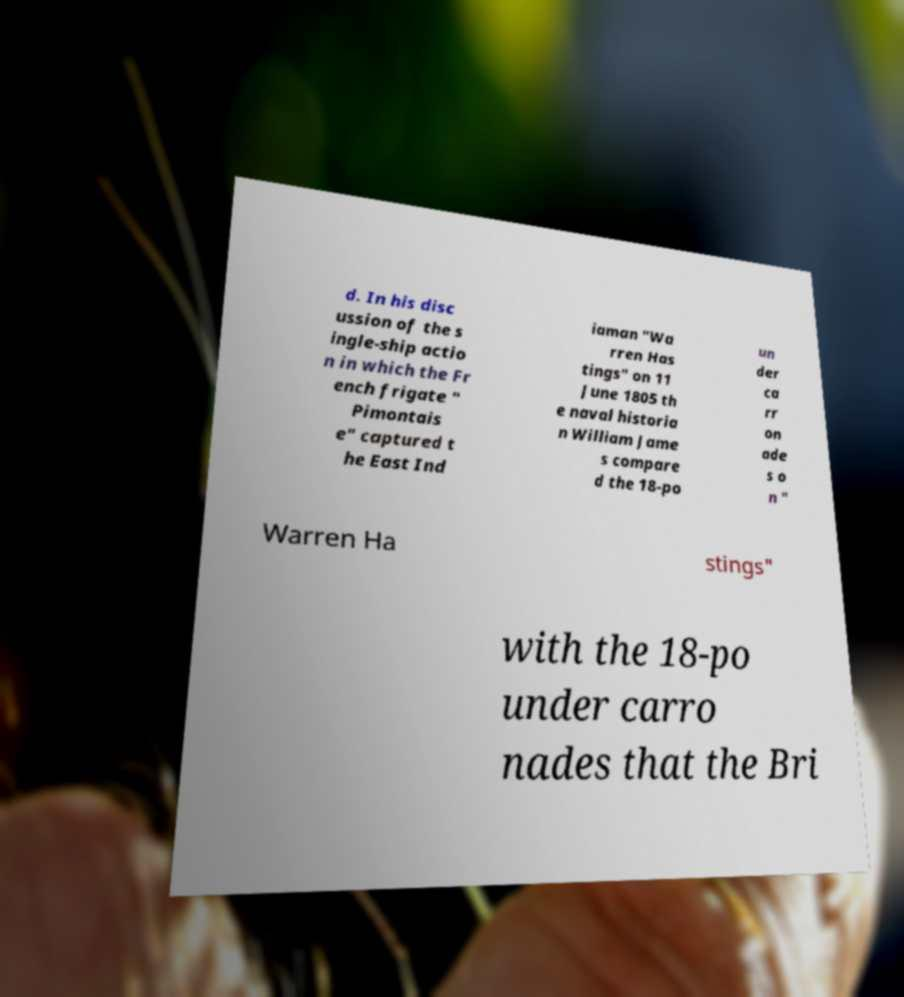There's text embedded in this image that I need extracted. Can you transcribe it verbatim? d. In his disc ussion of the s ingle-ship actio n in which the Fr ench frigate " Pimontais e" captured t he East Ind iaman "Wa rren Has tings" on 11 June 1805 th e naval historia n William Jame s compare d the 18-po un der ca rr on ade s o n " Warren Ha stings" with the 18-po under carro nades that the Bri 